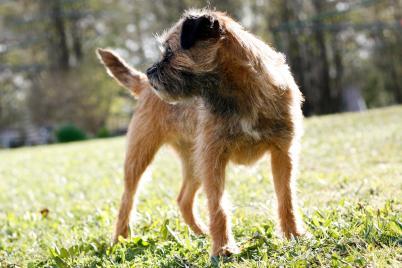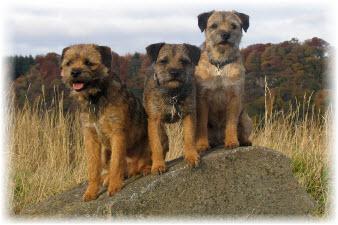The first image is the image on the left, the second image is the image on the right. For the images shown, is this caption "A single dog is standing alone in the grass in the image on the left." true? Answer yes or no. Yes. The first image is the image on the left, the second image is the image on the right. Assess this claim about the two images: "One image shows a dog standing wearing a harness and facing leftward.". Correct or not? Answer yes or no. No. 